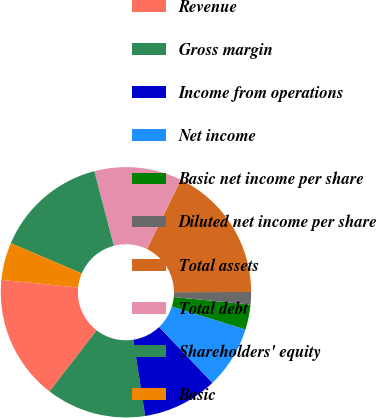Convert chart. <chart><loc_0><loc_0><loc_500><loc_500><pie_chart><fcel>Revenue<fcel>Gross margin<fcel>Income from operations<fcel>Net income<fcel>Basic net income per share<fcel>Diluted net income per share<fcel>Total assets<fcel>Total debt<fcel>Shareholders' equity<fcel>Basic<nl><fcel>16.13%<fcel>12.9%<fcel>9.68%<fcel>8.06%<fcel>3.23%<fcel>1.61%<fcel>17.74%<fcel>11.29%<fcel>14.52%<fcel>4.84%<nl></chart> 